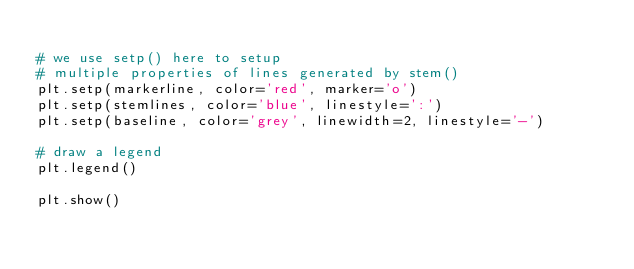Convert code to text. <code><loc_0><loc_0><loc_500><loc_500><_Python_>
# we use setp() here to setup 
# multiple properties of lines generated by stem()
plt.setp(markerline, color='red', marker='o')
plt.setp(stemlines, color='blue', linestyle=':')
plt.setp(baseline, color='grey', linewidth=2, linestyle='-')

# draw a legend
plt.legend()

plt.show()
</code> 